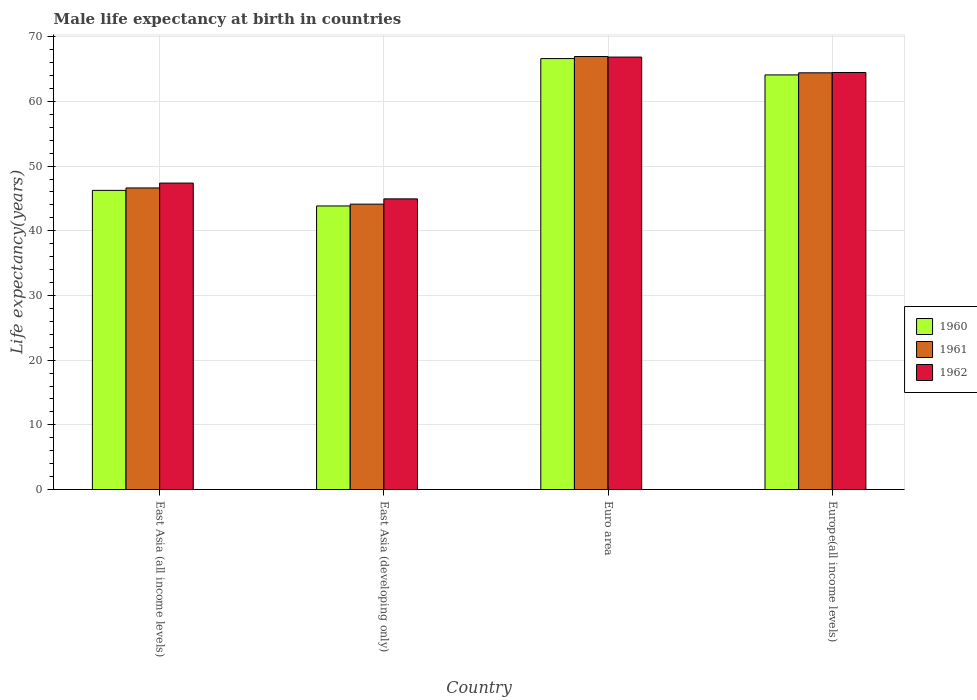How many different coloured bars are there?
Offer a terse response. 3. How many groups of bars are there?
Your answer should be very brief. 4. Are the number of bars per tick equal to the number of legend labels?
Make the answer very short. Yes. What is the male life expectancy at birth in 1960 in Europe(all income levels)?
Your response must be concise. 64.09. Across all countries, what is the maximum male life expectancy at birth in 1961?
Keep it short and to the point. 66.94. Across all countries, what is the minimum male life expectancy at birth in 1960?
Provide a succinct answer. 43.83. In which country was the male life expectancy at birth in 1961 maximum?
Keep it short and to the point. Euro area. In which country was the male life expectancy at birth in 1962 minimum?
Ensure brevity in your answer.  East Asia (developing only). What is the total male life expectancy at birth in 1960 in the graph?
Offer a very short reply. 220.8. What is the difference between the male life expectancy at birth in 1960 in East Asia (all income levels) and that in Euro area?
Keep it short and to the point. -20.38. What is the difference between the male life expectancy at birth in 1960 in Euro area and the male life expectancy at birth in 1961 in Europe(all income levels)?
Keep it short and to the point. 2.2. What is the average male life expectancy at birth in 1962 per country?
Your answer should be compact. 55.91. What is the difference between the male life expectancy at birth of/in 1961 and male life expectancy at birth of/in 1962 in East Asia (developing only)?
Offer a very short reply. -0.82. What is the ratio of the male life expectancy at birth in 1962 in East Asia (developing only) to that in Europe(all income levels)?
Your response must be concise. 0.7. What is the difference between the highest and the second highest male life expectancy at birth in 1962?
Provide a short and direct response. -2.38. What is the difference between the highest and the lowest male life expectancy at birth in 1961?
Offer a terse response. 22.82. In how many countries, is the male life expectancy at birth in 1960 greater than the average male life expectancy at birth in 1960 taken over all countries?
Keep it short and to the point. 2. What does the 3rd bar from the right in East Asia (developing only) represents?
Your response must be concise. 1960. Are all the bars in the graph horizontal?
Your answer should be very brief. No. What is the difference between two consecutive major ticks on the Y-axis?
Make the answer very short. 10. Are the values on the major ticks of Y-axis written in scientific E-notation?
Make the answer very short. No. Does the graph contain any zero values?
Ensure brevity in your answer.  No. Where does the legend appear in the graph?
Provide a succinct answer. Center right. How many legend labels are there?
Ensure brevity in your answer.  3. How are the legend labels stacked?
Ensure brevity in your answer.  Vertical. What is the title of the graph?
Keep it short and to the point. Male life expectancy at birth in countries. Does "1998" appear as one of the legend labels in the graph?
Give a very brief answer. No. What is the label or title of the Y-axis?
Offer a terse response. Life expectancy(years). What is the Life expectancy(years) of 1960 in East Asia (all income levels)?
Give a very brief answer. 46.25. What is the Life expectancy(years) of 1961 in East Asia (all income levels)?
Your response must be concise. 46.62. What is the Life expectancy(years) of 1962 in East Asia (all income levels)?
Provide a succinct answer. 47.38. What is the Life expectancy(years) in 1960 in East Asia (developing only)?
Offer a very short reply. 43.83. What is the Life expectancy(years) of 1961 in East Asia (developing only)?
Give a very brief answer. 44.12. What is the Life expectancy(years) in 1962 in East Asia (developing only)?
Provide a short and direct response. 44.93. What is the Life expectancy(years) of 1960 in Euro area?
Give a very brief answer. 66.62. What is the Life expectancy(years) of 1961 in Euro area?
Offer a very short reply. 66.94. What is the Life expectancy(years) of 1962 in Euro area?
Provide a short and direct response. 66.85. What is the Life expectancy(years) in 1960 in Europe(all income levels)?
Provide a succinct answer. 64.09. What is the Life expectancy(years) of 1961 in Europe(all income levels)?
Keep it short and to the point. 64.42. What is the Life expectancy(years) in 1962 in Europe(all income levels)?
Your answer should be very brief. 64.47. Across all countries, what is the maximum Life expectancy(years) in 1960?
Ensure brevity in your answer.  66.62. Across all countries, what is the maximum Life expectancy(years) of 1961?
Offer a very short reply. 66.94. Across all countries, what is the maximum Life expectancy(years) in 1962?
Your answer should be very brief. 66.85. Across all countries, what is the minimum Life expectancy(years) of 1960?
Keep it short and to the point. 43.83. Across all countries, what is the minimum Life expectancy(years) of 1961?
Provide a short and direct response. 44.12. Across all countries, what is the minimum Life expectancy(years) of 1962?
Ensure brevity in your answer.  44.93. What is the total Life expectancy(years) in 1960 in the graph?
Provide a succinct answer. 220.8. What is the total Life expectancy(years) of 1961 in the graph?
Provide a short and direct response. 222.09. What is the total Life expectancy(years) in 1962 in the graph?
Provide a short and direct response. 223.63. What is the difference between the Life expectancy(years) in 1960 in East Asia (all income levels) and that in East Asia (developing only)?
Make the answer very short. 2.41. What is the difference between the Life expectancy(years) of 1961 in East Asia (all income levels) and that in East Asia (developing only)?
Offer a very short reply. 2.5. What is the difference between the Life expectancy(years) of 1962 in East Asia (all income levels) and that in East Asia (developing only)?
Ensure brevity in your answer.  2.44. What is the difference between the Life expectancy(years) in 1960 in East Asia (all income levels) and that in Euro area?
Your answer should be compact. -20.38. What is the difference between the Life expectancy(years) in 1961 in East Asia (all income levels) and that in Euro area?
Ensure brevity in your answer.  -20.32. What is the difference between the Life expectancy(years) in 1962 in East Asia (all income levels) and that in Euro area?
Ensure brevity in your answer.  -19.47. What is the difference between the Life expectancy(years) of 1960 in East Asia (all income levels) and that in Europe(all income levels)?
Your answer should be very brief. -17.85. What is the difference between the Life expectancy(years) in 1961 in East Asia (all income levels) and that in Europe(all income levels)?
Your response must be concise. -17.8. What is the difference between the Life expectancy(years) of 1962 in East Asia (all income levels) and that in Europe(all income levels)?
Your response must be concise. -17.09. What is the difference between the Life expectancy(years) of 1960 in East Asia (developing only) and that in Euro area?
Make the answer very short. -22.79. What is the difference between the Life expectancy(years) in 1961 in East Asia (developing only) and that in Euro area?
Make the answer very short. -22.82. What is the difference between the Life expectancy(years) in 1962 in East Asia (developing only) and that in Euro area?
Ensure brevity in your answer.  -21.92. What is the difference between the Life expectancy(years) of 1960 in East Asia (developing only) and that in Europe(all income levels)?
Make the answer very short. -20.26. What is the difference between the Life expectancy(years) of 1961 in East Asia (developing only) and that in Europe(all income levels)?
Give a very brief answer. -20.3. What is the difference between the Life expectancy(years) of 1962 in East Asia (developing only) and that in Europe(all income levels)?
Ensure brevity in your answer.  -19.54. What is the difference between the Life expectancy(years) in 1960 in Euro area and that in Europe(all income levels)?
Provide a short and direct response. 2.53. What is the difference between the Life expectancy(years) in 1961 in Euro area and that in Europe(all income levels)?
Offer a terse response. 2.52. What is the difference between the Life expectancy(years) in 1962 in Euro area and that in Europe(all income levels)?
Ensure brevity in your answer.  2.38. What is the difference between the Life expectancy(years) in 1960 in East Asia (all income levels) and the Life expectancy(years) in 1961 in East Asia (developing only)?
Offer a terse response. 2.13. What is the difference between the Life expectancy(years) of 1960 in East Asia (all income levels) and the Life expectancy(years) of 1962 in East Asia (developing only)?
Offer a very short reply. 1.31. What is the difference between the Life expectancy(years) in 1961 in East Asia (all income levels) and the Life expectancy(years) in 1962 in East Asia (developing only)?
Ensure brevity in your answer.  1.69. What is the difference between the Life expectancy(years) of 1960 in East Asia (all income levels) and the Life expectancy(years) of 1961 in Euro area?
Provide a succinct answer. -20.69. What is the difference between the Life expectancy(years) of 1960 in East Asia (all income levels) and the Life expectancy(years) of 1962 in Euro area?
Keep it short and to the point. -20.6. What is the difference between the Life expectancy(years) of 1961 in East Asia (all income levels) and the Life expectancy(years) of 1962 in Euro area?
Ensure brevity in your answer.  -20.23. What is the difference between the Life expectancy(years) in 1960 in East Asia (all income levels) and the Life expectancy(years) in 1961 in Europe(all income levels)?
Make the answer very short. -18.17. What is the difference between the Life expectancy(years) in 1960 in East Asia (all income levels) and the Life expectancy(years) in 1962 in Europe(all income levels)?
Offer a terse response. -18.22. What is the difference between the Life expectancy(years) in 1961 in East Asia (all income levels) and the Life expectancy(years) in 1962 in Europe(all income levels)?
Give a very brief answer. -17.85. What is the difference between the Life expectancy(years) of 1960 in East Asia (developing only) and the Life expectancy(years) of 1961 in Euro area?
Provide a succinct answer. -23.1. What is the difference between the Life expectancy(years) in 1960 in East Asia (developing only) and the Life expectancy(years) in 1962 in Euro area?
Your answer should be very brief. -23.02. What is the difference between the Life expectancy(years) of 1961 in East Asia (developing only) and the Life expectancy(years) of 1962 in Euro area?
Your answer should be very brief. -22.73. What is the difference between the Life expectancy(years) of 1960 in East Asia (developing only) and the Life expectancy(years) of 1961 in Europe(all income levels)?
Offer a terse response. -20.58. What is the difference between the Life expectancy(years) in 1960 in East Asia (developing only) and the Life expectancy(years) in 1962 in Europe(all income levels)?
Provide a short and direct response. -20.63. What is the difference between the Life expectancy(years) of 1961 in East Asia (developing only) and the Life expectancy(years) of 1962 in Europe(all income levels)?
Your answer should be compact. -20.35. What is the difference between the Life expectancy(years) of 1960 in Euro area and the Life expectancy(years) of 1961 in Europe(all income levels)?
Give a very brief answer. 2.2. What is the difference between the Life expectancy(years) of 1960 in Euro area and the Life expectancy(years) of 1962 in Europe(all income levels)?
Keep it short and to the point. 2.15. What is the difference between the Life expectancy(years) in 1961 in Euro area and the Life expectancy(years) in 1962 in Europe(all income levels)?
Keep it short and to the point. 2.47. What is the average Life expectancy(years) in 1960 per country?
Ensure brevity in your answer.  55.2. What is the average Life expectancy(years) in 1961 per country?
Provide a short and direct response. 55.52. What is the average Life expectancy(years) of 1962 per country?
Make the answer very short. 55.91. What is the difference between the Life expectancy(years) in 1960 and Life expectancy(years) in 1961 in East Asia (all income levels)?
Keep it short and to the point. -0.37. What is the difference between the Life expectancy(years) in 1960 and Life expectancy(years) in 1962 in East Asia (all income levels)?
Offer a very short reply. -1.13. What is the difference between the Life expectancy(years) in 1961 and Life expectancy(years) in 1962 in East Asia (all income levels)?
Make the answer very short. -0.75. What is the difference between the Life expectancy(years) in 1960 and Life expectancy(years) in 1961 in East Asia (developing only)?
Provide a succinct answer. -0.28. What is the difference between the Life expectancy(years) of 1960 and Life expectancy(years) of 1962 in East Asia (developing only)?
Keep it short and to the point. -1.1. What is the difference between the Life expectancy(years) in 1961 and Life expectancy(years) in 1962 in East Asia (developing only)?
Provide a short and direct response. -0.82. What is the difference between the Life expectancy(years) of 1960 and Life expectancy(years) of 1961 in Euro area?
Your response must be concise. -0.32. What is the difference between the Life expectancy(years) of 1960 and Life expectancy(years) of 1962 in Euro area?
Offer a terse response. -0.23. What is the difference between the Life expectancy(years) of 1961 and Life expectancy(years) of 1962 in Euro area?
Your answer should be compact. 0.09. What is the difference between the Life expectancy(years) in 1960 and Life expectancy(years) in 1961 in Europe(all income levels)?
Keep it short and to the point. -0.32. What is the difference between the Life expectancy(years) in 1960 and Life expectancy(years) in 1962 in Europe(all income levels)?
Provide a short and direct response. -0.37. What is the difference between the Life expectancy(years) in 1961 and Life expectancy(years) in 1962 in Europe(all income levels)?
Your answer should be compact. -0.05. What is the ratio of the Life expectancy(years) of 1960 in East Asia (all income levels) to that in East Asia (developing only)?
Ensure brevity in your answer.  1.05. What is the ratio of the Life expectancy(years) in 1961 in East Asia (all income levels) to that in East Asia (developing only)?
Your answer should be very brief. 1.06. What is the ratio of the Life expectancy(years) of 1962 in East Asia (all income levels) to that in East Asia (developing only)?
Ensure brevity in your answer.  1.05. What is the ratio of the Life expectancy(years) of 1960 in East Asia (all income levels) to that in Euro area?
Ensure brevity in your answer.  0.69. What is the ratio of the Life expectancy(years) of 1961 in East Asia (all income levels) to that in Euro area?
Your answer should be compact. 0.7. What is the ratio of the Life expectancy(years) of 1962 in East Asia (all income levels) to that in Euro area?
Your answer should be very brief. 0.71. What is the ratio of the Life expectancy(years) of 1960 in East Asia (all income levels) to that in Europe(all income levels)?
Your response must be concise. 0.72. What is the ratio of the Life expectancy(years) of 1961 in East Asia (all income levels) to that in Europe(all income levels)?
Your response must be concise. 0.72. What is the ratio of the Life expectancy(years) in 1962 in East Asia (all income levels) to that in Europe(all income levels)?
Offer a terse response. 0.73. What is the ratio of the Life expectancy(years) of 1960 in East Asia (developing only) to that in Euro area?
Keep it short and to the point. 0.66. What is the ratio of the Life expectancy(years) in 1961 in East Asia (developing only) to that in Euro area?
Your answer should be compact. 0.66. What is the ratio of the Life expectancy(years) of 1962 in East Asia (developing only) to that in Euro area?
Your answer should be compact. 0.67. What is the ratio of the Life expectancy(years) of 1960 in East Asia (developing only) to that in Europe(all income levels)?
Provide a succinct answer. 0.68. What is the ratio of the Life expectancy(years) of 1961 in East Asia (developing only) to that in Europe(all income levels)?
Provide a succinct answer. 0.68. What is the ratio of the Life expectancy(years) in 1962 in East Asia (developing only) to that in Europe(all income levels)?
Make the answer very short. 0.7. What is the ratio of the Life expectancy(years) in 1960 in Euro area to that in Europe(all income levels)?
Provide a succinct answer. 1.04. What is the ratio of the Life expectancy(years) of 1961 in Euro area to that in Europe(all income levels)?
Ensure brevity in your answer.  1.04. What is the ratio of the Life expectancy(years) of 1962 in Euro area to that in Europe(all income levels)?
Your answer should be compact. 1.04. What is the difference between the highest and the second highest Life expectancy(years) in 1960?
Your answer should be very brief. 2.53. What is the difference between the highest and the second highest Life expectancy(years) in 1961?
Make the answer very short. 2.52. What is the difference between the highest and the second highest Life expectancy(years) of 1962?
Provide a short and direct response. 2.38. What is the difference between the highest and the lowest Life expectancy(years) of 1960?
Ensure brevity in your answer.  22.79. What is the difference between the highest and the lowest Life expectancy(years) in 1961?
Keep it short and to the point. 22.82. What is the difference between the highest and the lowest Life expectancy(years) of 1962?
Keep it short and to the point. 21.92. 